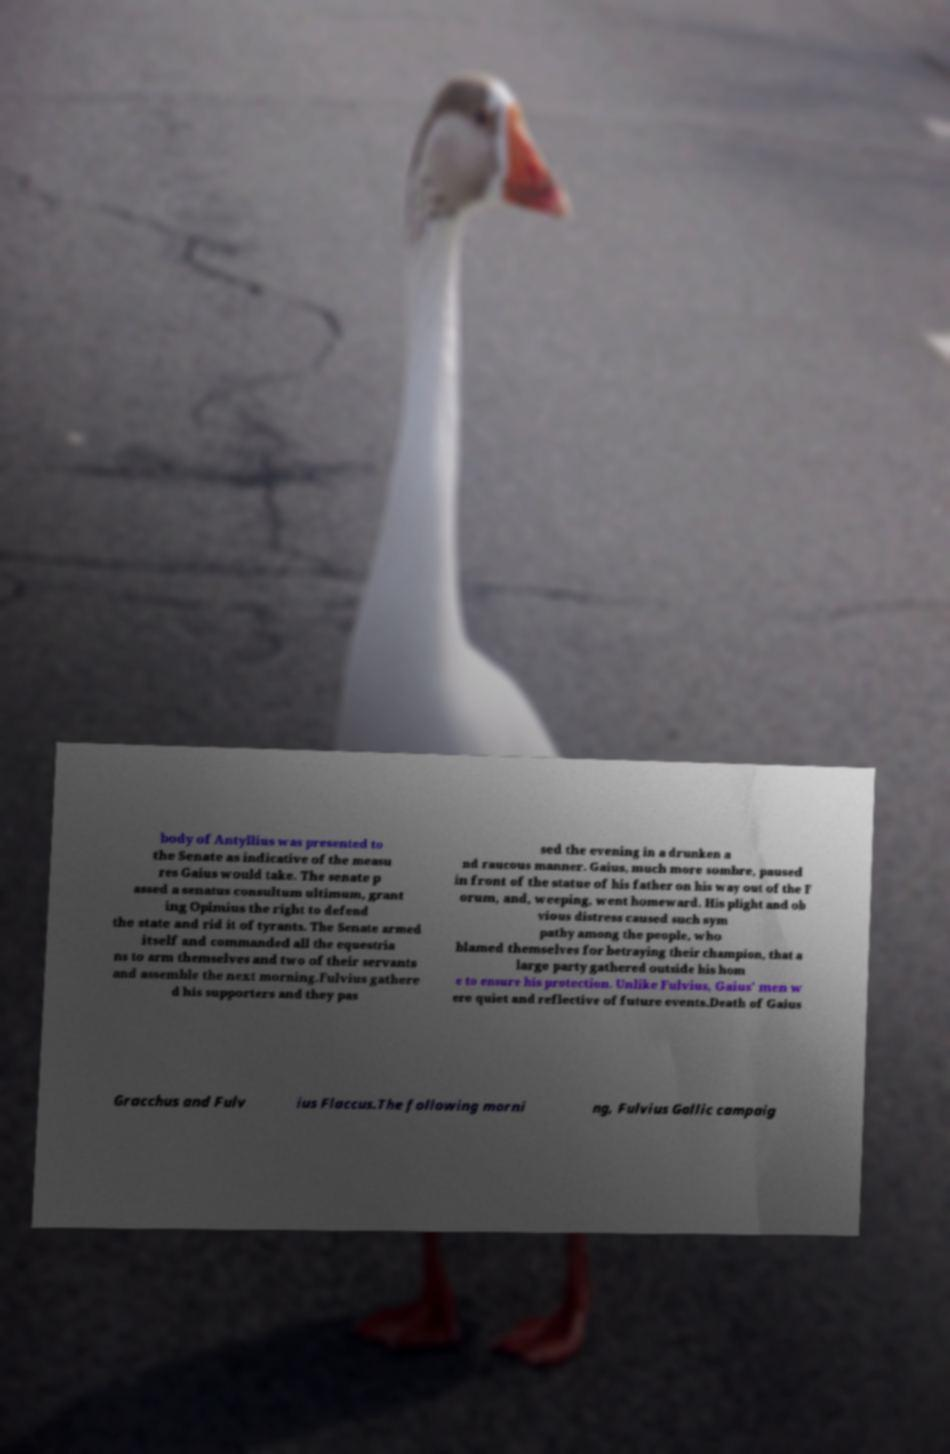Can you read and provide the text displayed in the image?This photo seems to have some interesting text. Can you extract and type it out for me? body of Antyllius was presented to the Senate as indicative of the measu res Gaius would take. The senate p assed a senatus consultum ultimum, grant ing Opimius the right to defend the state and rid it of tyrants. The Senate armed itself and commanded all the equestria ns to arm themselves and two of their servants and assemble the next morning.Fulvius gathere d his supporters and they pas sed the evening in a drunken a nd raucous manner. Gaius, much more sombre, paused in front of the statue of his father on his way out of the F orum, and, weeping, went homeward. His plight and ob vious distress caused such sym pathy among the people, who blamed themselves for betraying their champion, that a large party gathered outside his hom e to ensure his protection. Unlike Fulvius, Gaius' men w ere quiet and reflective of future events.Death of Gaius Gracchus and Fulv ius Flaccus.The following morni ng, Fulvius Gallic campaig 